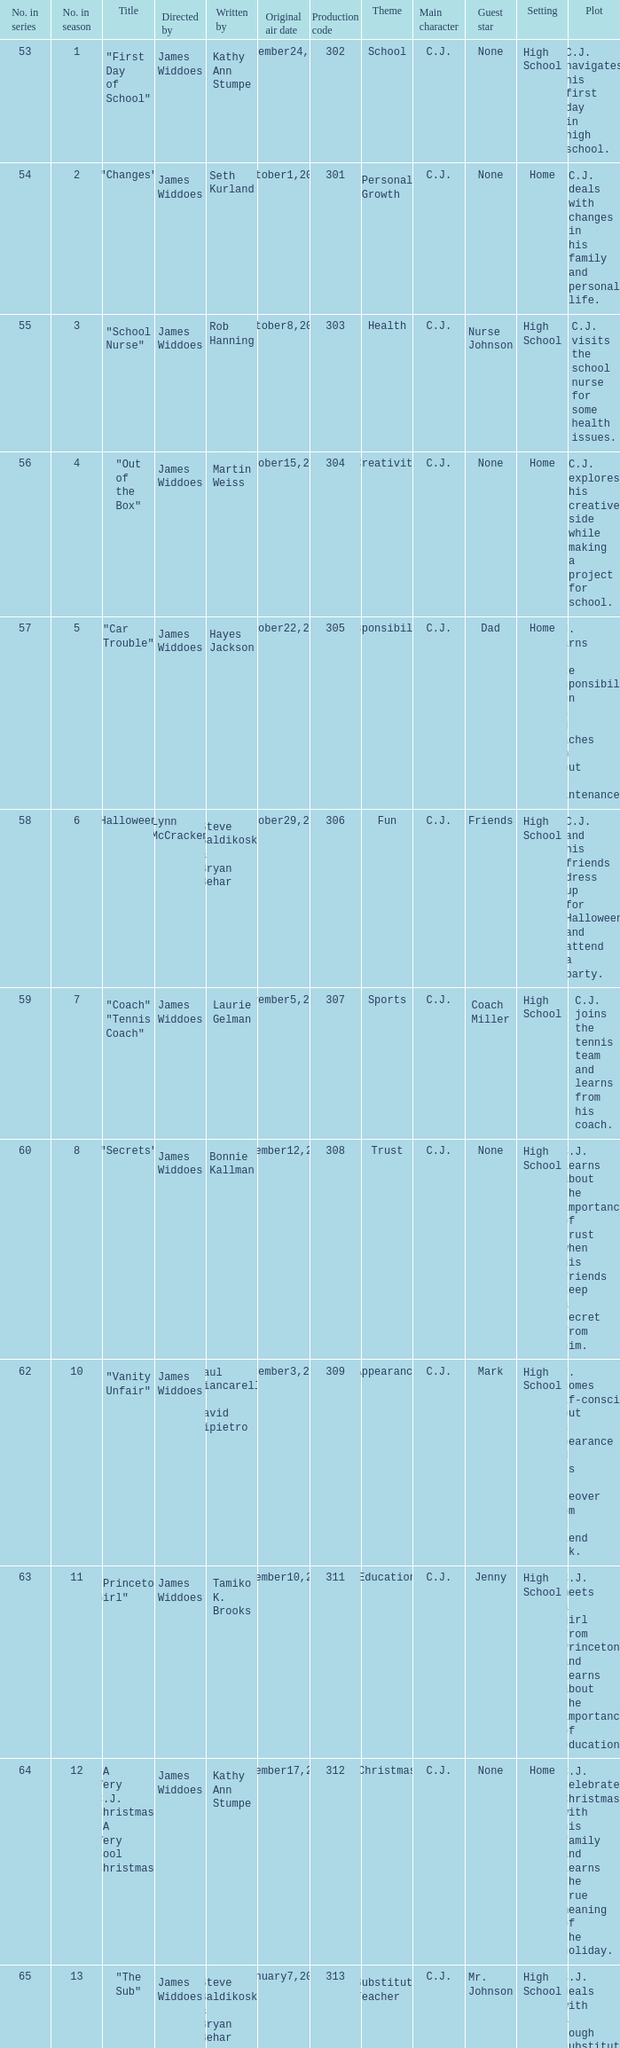What is the production code for episode 3 of the season? 303.0. 